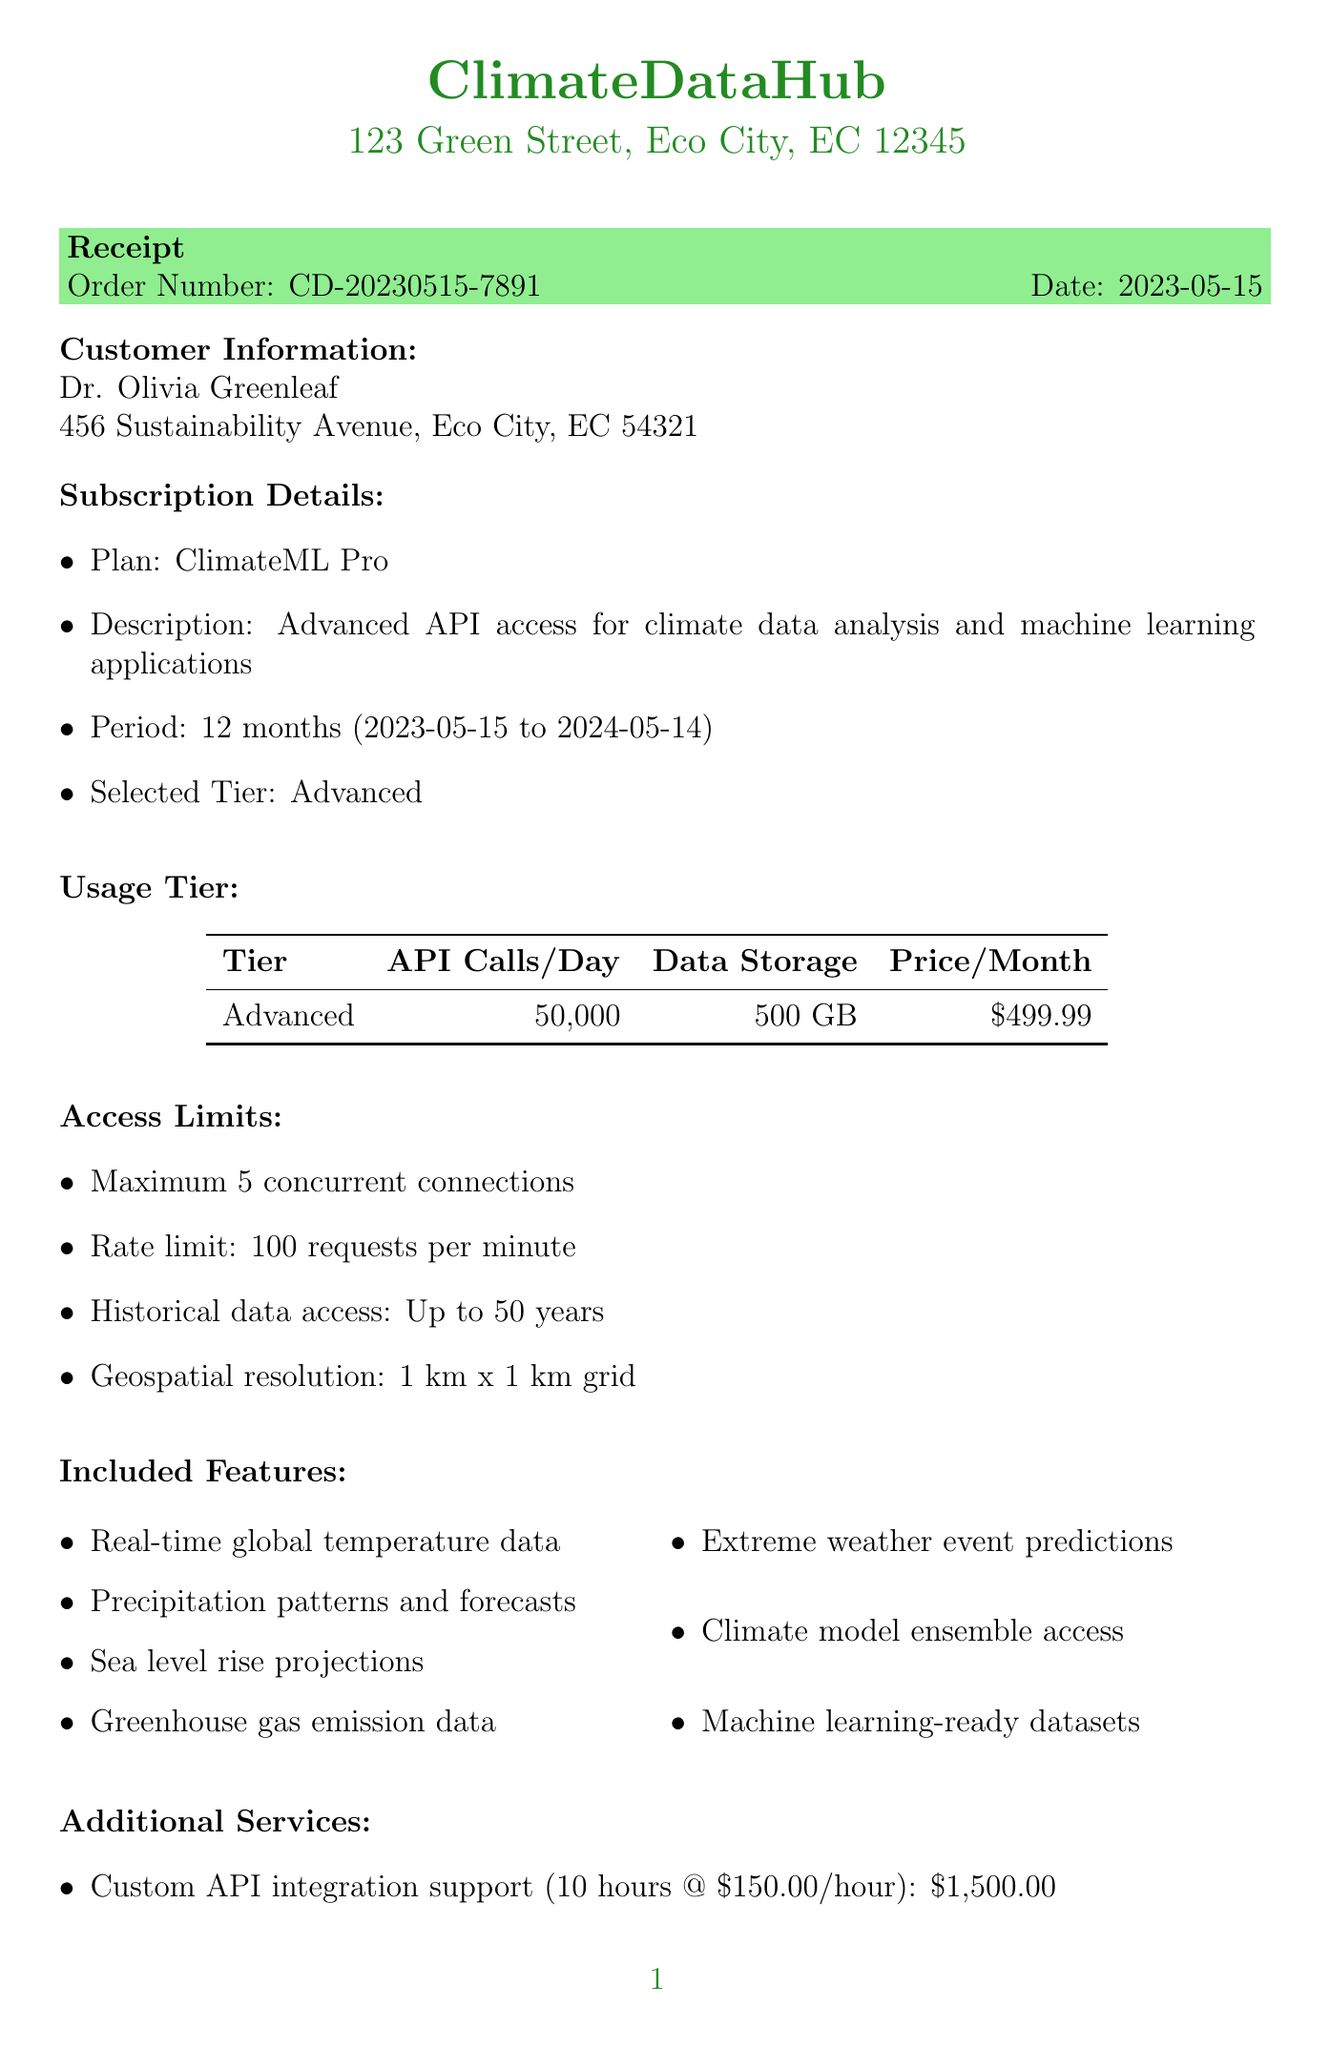What is the name of the company? The company's name is listed at the top of the document.
Answer: ClimateDataHub What is the total amount paid? The total amount is summarized in the payment section of the document.
Answer: $8,099.87 What subscription plan was selected? The selected plan is stated under subscription details.
Answer: ClimateML Pro How many API calls are allowed per day in the selected tier? This information is found in the usage tier table for the selected tier.
Answer: 50,000 What is the duration of the subscription period? The subscription period is mentioned in the subscription details section.
Answer: 12 months What is the tax rate applied to the payment? The tax rate is shown in the payment summary section.
Answer: 8% What additional service has a price of $299.99? This price is associated with one of the additional services listed in the document.
Answer: Climate data visualization toolkit How many concurrent connections are allowed? This limit is specified under the access limits section of the document.
Answer: Maximum 5 concurrent connections Who is the customer? The customer information is listed in the customer information section.
Answer: Dr. Olivia Greenleaf 